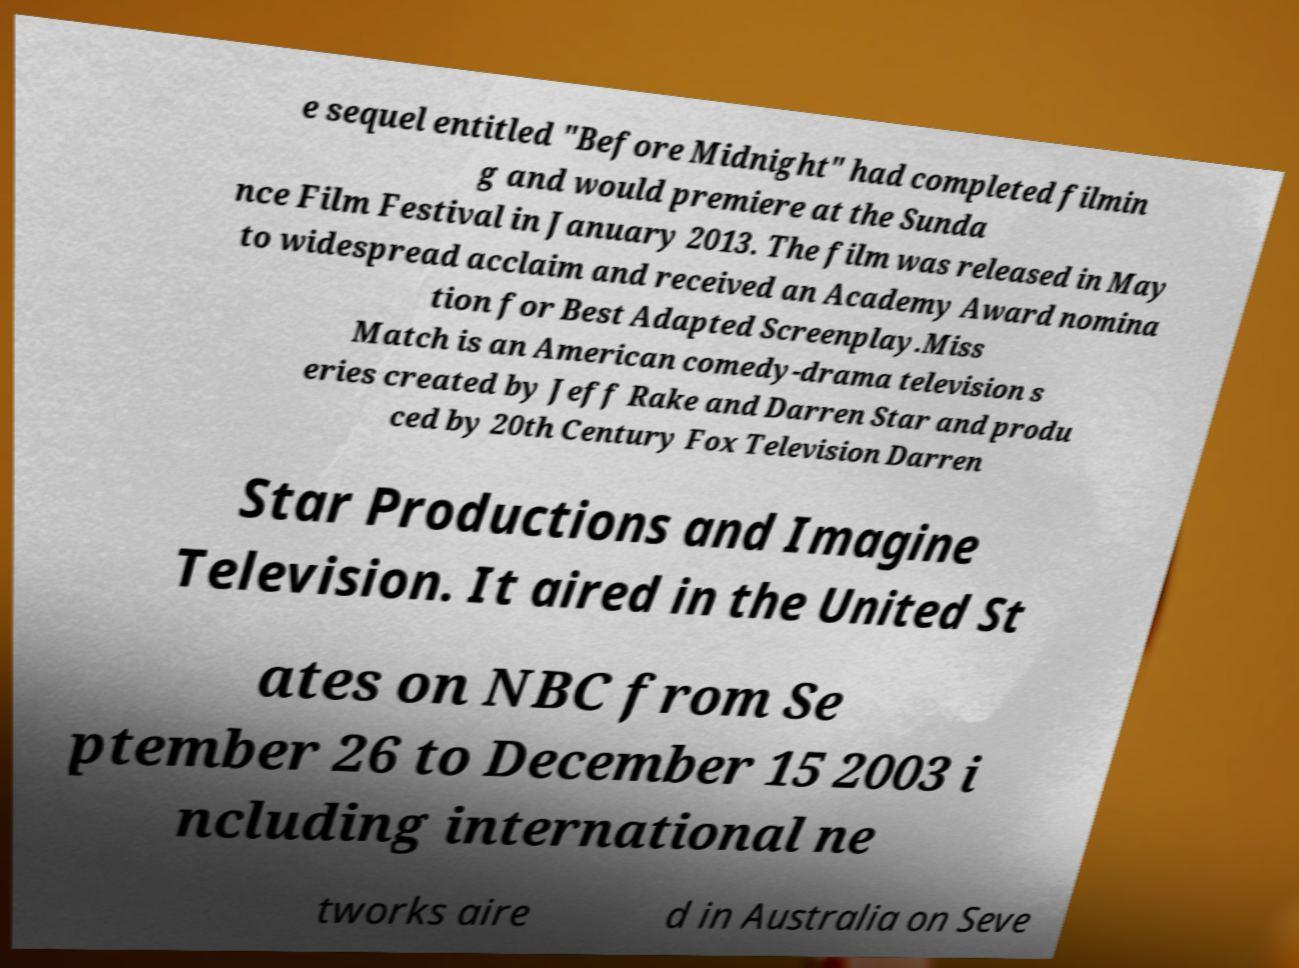I need the written content from this picture converted into text. Can you do that? e sequel entitled "Before Midnight" had completed filmin g and would premiere at the Sunda nce Film Festival in January 2013. The film was released in May to widespread acclaim and received an Academy Award nomina tion for Best Adapted Screenplay.Miss Match is an American comedy-drama television s eries created by Jeff Rake and Darren Star and produ ced by 20th Century Fox Television Darren Star Productions and Imagine Television. It aired in the United St ates on NBC from Se ptember 26 to December 15 2003 i ncluding international ne tworks aire d in Australia on Seve 